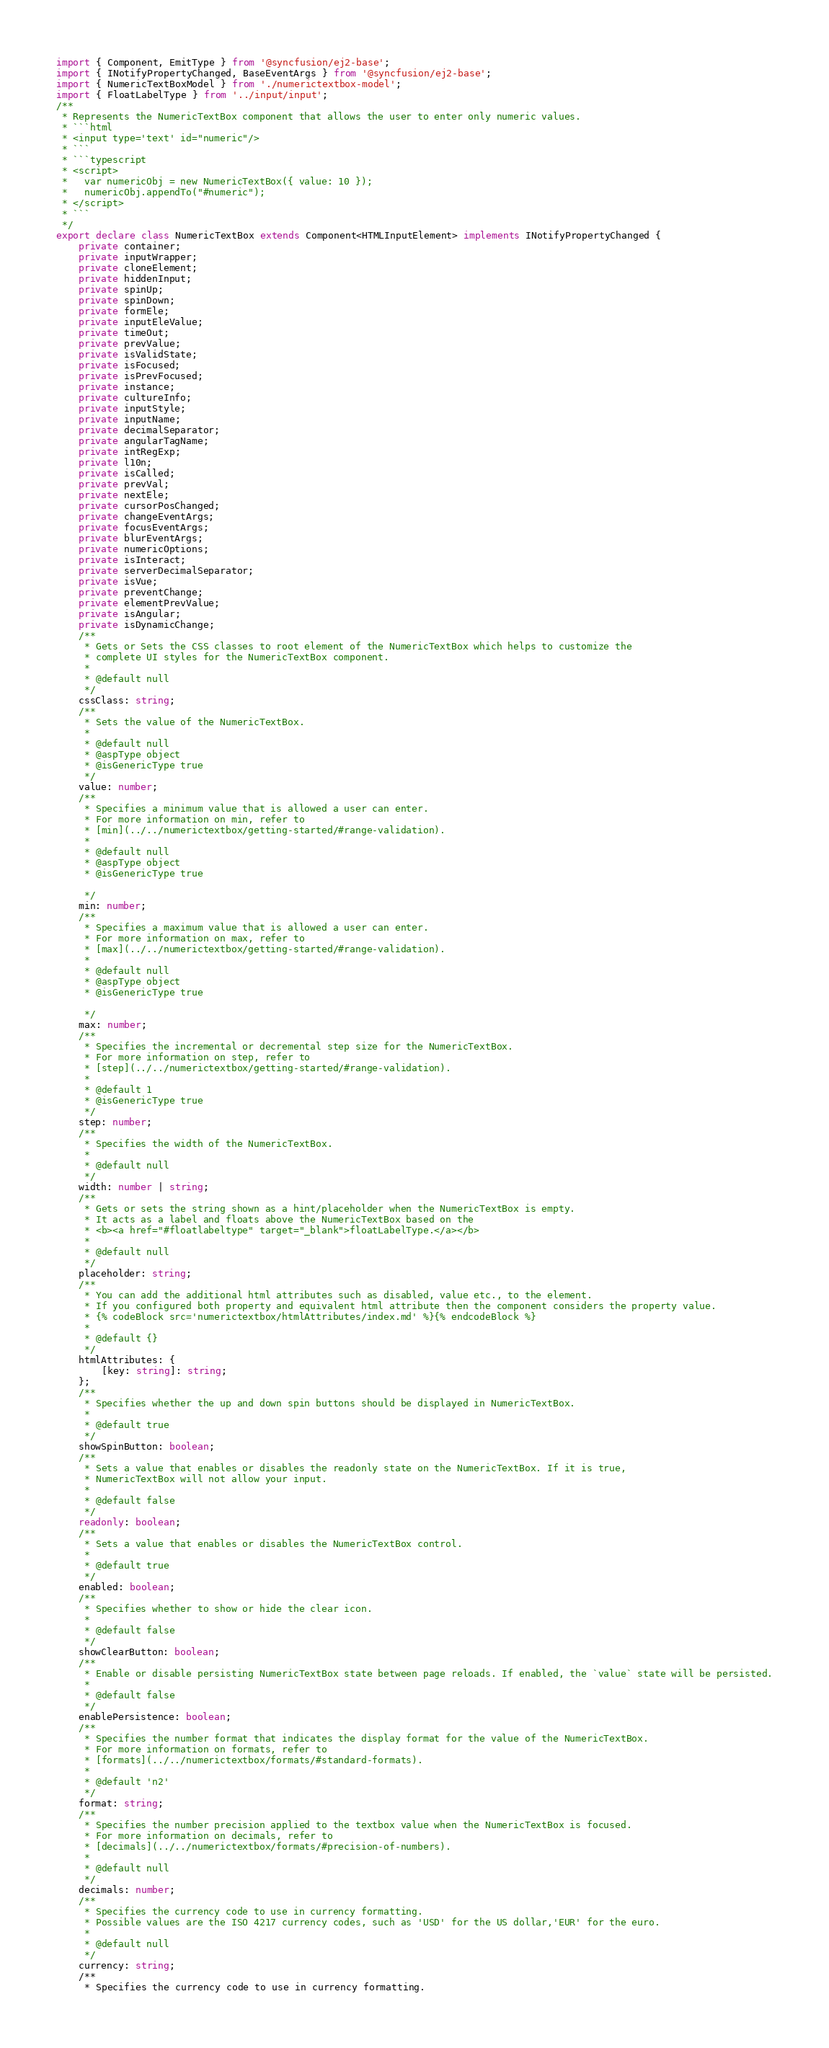<code> <loc_0><loc_0><loc_500><loc_500><_TypeScript_>import { Component, EmitType } from '@syncfusion/ej2-base';
import { INotifyPropertyChanged, BaseEventArgs } from '@syncfusion/ej2-base';
import { NumericTextBoxModel } from './numerictextbox-model';
import { FloatLabelType } from '../input/input';
/**
 * Represents the NumericTextBox component that allows the user to enter only numeric values.
 * ```html
 * <input type='text' id="numeric"/>
 * ```
 * ```typescript
 * <script>
 *   var numericObj = new NumericTextBox({ value: 10 });
 *   numericObj.appendTo("#numeric");
 * </script>
 * ```
 */
export declare class NumericTextBox extends Component<HTMLInputElement> implements INotifyPropertyChanged {
    private container;
    private inputWrapper;
    private cloneElement;
    private hiddenInput;
    private spinUp;
    private spinDown;
    private formEle;
    private inputEleValue;
    private timeOut;
    private prevValue;
    private isValidState;
    private isFocused;
    private isPrevFocused;
    private instance;
    private cultureInfo;
    private inputStyle;
    private inputName;
    private decimalSeparator;
    private angularTagName;
    private intRegExp;
    private l10n;
    private isCalled;
    private prevVal;
    private nextEle;
    private cursorPosChanged;
    private changeEventArgs;
    private focusEventArgs;
    private blurEventArgs;
    private numericOptions;
    private isInteract;
    private serverDecimalSeparator;
    private isVue;
    private preventChange;
    private elementPrevValue;
    private isAngular;
    private isDynamicChange;
    /**
     * Gets or Sets the CSS classes to root element of the NumericTextBox which helps to customize the
     * complete UI styles for the NumericTextBox component.
     *
     * @default null
     */
    cssClass: string;
    /**
     * Sets the value of the NumericTextBox.
     *
     * @default null
     * @aspType object
     * @isGenericType true
     */
    value: number;
    /**
     * Specifies a minimum value that is allowed a user can enter.
     * For more information on min, refer to
     * [min](../../numerictextbox/getting-started/#range-validation).
     *
     * @default null
     * @aspType object
     * @isGenericType true

     */
    min: number;
    /**
     * Specifies a maximum value that is allowed a user can enter.
     * For more information on max, refer to
     * [max](../../numerictextbox/getting-started/#range-validation).
     *
     * @default null
     * @aspType object
     * @isGenericType true

     */
    max: number;
    /**
     * Specifies the incremental or decremental step size for the NumericTextBox.
     * For more information on step, refer to
     * [step](../../numerictextbox/getting-started/#range-validation).
     *
     * @default 1
     * @isGenericType true
     */
    step: number;
    /**
     * Specifies the width of the NumericTextBox.
     *
     * @default null
     */
    width: number | string;
    /**
     * Gets or sets the string shown as a hint/placeholder when the NumericTextBox is empty.
     * It acts as a label and floats above the NumericTextBox based on the
     * <b><a href="#floatlabeltype" target="_blank">floatLabelType.</a></b>
     *
     * @default null
     */
    placeholder: string;
    /**
     * You can add the additional html attributes such as disabled, value etc., to the element.
     * If you configured both property and equivalent html attribute then the component considers the property value.
     * {% codeBlock src='numerictextbox/htmlAttributes/index.md' %}{% endcodeBlock %}
     *
     * @default {}
     */
    htmlAttributes: {
        [key: string]: string;
    };
    /**
     * Specifies whether the up and down spin buttons should be displayed in NumericTextBox.
     *
     * @default true
     */
    showSpinButton: boolean;
    /**
     * Sets a value that enables or disables the readonly state on the NumericTextBox. If it is true,
     * NumericTextBox will not allow your input.
     *
     * @default false
     */
    readonly: boolean;
    /**
     * Sets a value that enables or disables the NumericTextBox control.
     *
     * @default true
     */
    enabled: boolean;
    /**
     * Specifies whether to show or hide the clear icon.
     *
     * @default false
     */
    showClearButton: boolean;
    /**
     * Enable or disable persisting NumericTextBox state between page reloads. If enabled, the `value` state will be persisted.
     *
     * @default false
     */
    enablePersistence: boolean;
    /**
     * Specifies the number format that indicates the display format for the value of the NumericTextBox.
     * For more information on formats, refer to
     * [formats](../../numerictextbox/formats/#standard-formats).
     *
     * @default 'n2'
     */
    format: string;
    /**
     * Specifies the number precision applied to the textbox value when the NumericTextBox is focused.
     * For more information on decimals, refer to
     * [decimals](../../numerictextbox/formats/#precision-of-numbers).
     *
     * @default null
     */
    decimals: number;
    /**
     * Specifies the currency code to use in currency formatting.
     * Possible values are the ISO 4217 currency codes, such as 'USD' for the US dollar,'EUR' for the euro.
     *
     * @default null
     */
    currency: string;
    /**
     * Specifies the currency code to use in currency formatting.</code> 